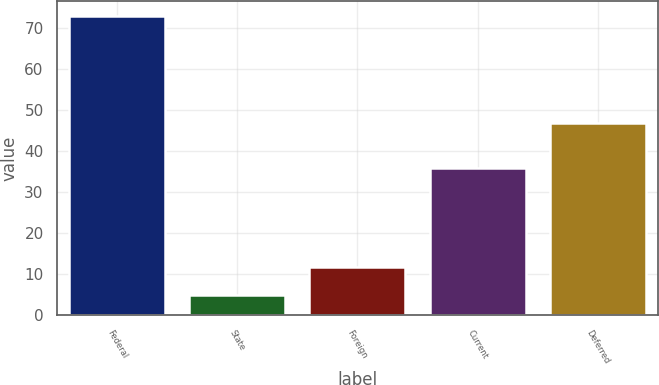Convert chart to OTSL. <chart><loc_0><loc_0><loc_500><loc_500><bar_chart><fcel>Federal<fcel>State<fcel>Foreign<fcel>Current<fcel>Deferred<nl><fcel>73<fcel>5<fcel>11.8<fcel>36<fcel>47<nl></chart> 